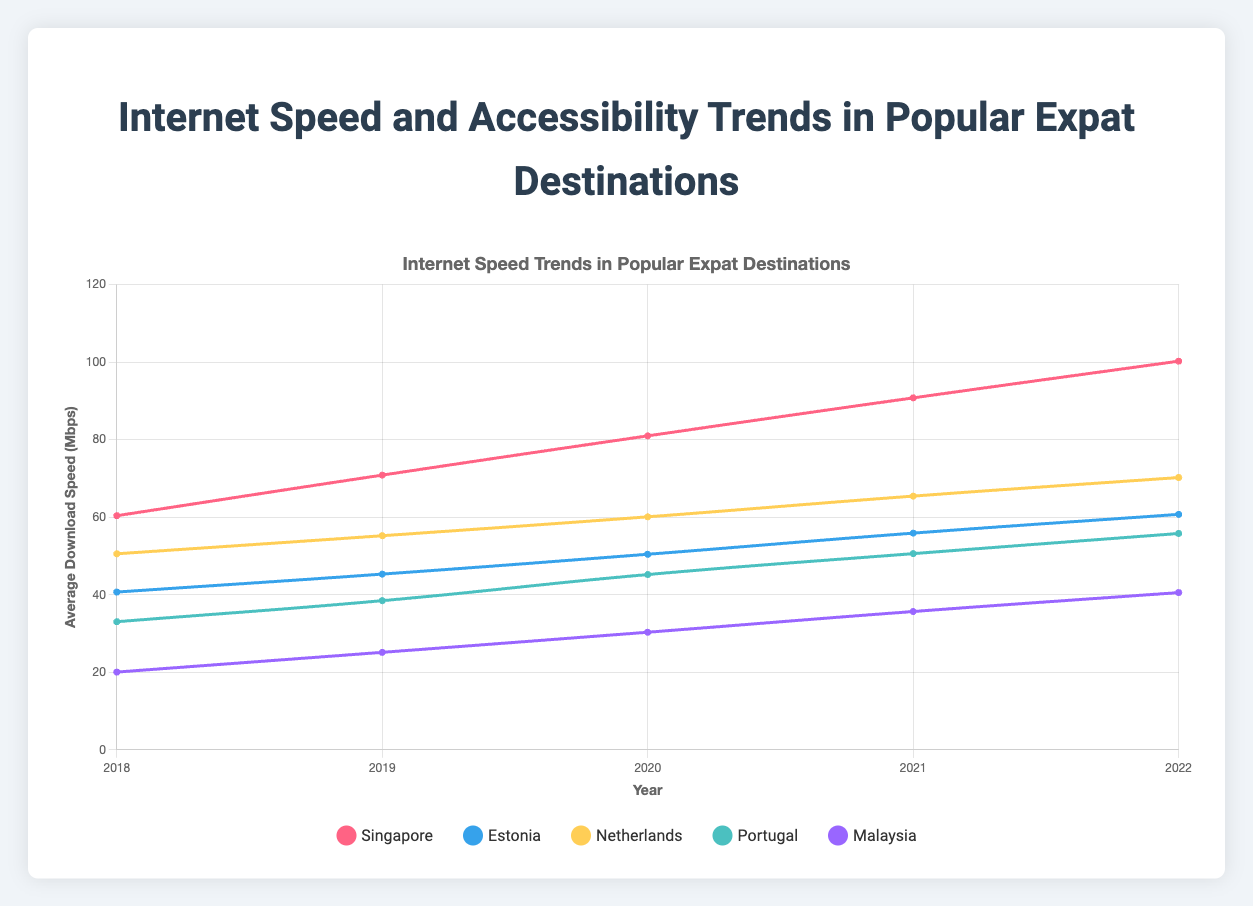What's the overall trend for internet speed in Singapore from 2018 to 2022? The line chart for Singapore shows a steady increase in average download speed from 60.39 Mbps in 2018 to 100.25 Mbps in 2022. By observing the plotted line, we can see consistent growth throughout these years.
Answer: Steady increase Which country had the highest accessibility score in 2020? By quickly scanning the lines and labels for accessibility scores, the highest value in 2020 is evident. Singapore had the highest accessibility score of 93, as indicated by the topmost point on the graph for that year.
Answer: Singapore In which year did Malaysia see the highest increase in average download speed compared to the previous year? Reviewing the line plot for Malaysia, the largest increase can be observed between 2018 and 2019, where the speed jumped from 20.05 Mbps to 25.14 Mbps, an increase of 5.09 Mbps.
Answer: 2019 How did Portugal's average download speed in 2022 compare to its speed in 2018? Portugal’s average download speed in 2018 was 33.04 Mbps, and in 2022 it was 55.80 Mbps. The comparison calculation shows that the speed increased by 22.76 Mbps over these years.
Answer: Increased by 22.76 Mbps Which country had the lowest average download speed in 2021? Scanning the chart for the lowest point in 2021, Malaysia shows the lowest average download speed at 35.67 Mbps. This can be seen by observing the bottommost line for that year.
Answer: Malaysia What is the combined average download speed for Estonia and Netherlands in 2022? For 2022, Estonia's speed is 60.73 Mbps and the Netherlands' speed is 70.23 Mbps. The combined average is calculated as (60.73 + 70.23) / 2.
Answer: 65.48 Mbps Compare the average download speed growth between Singapore and Estonia from 2018 to 2022. Singapore's download speed grew from 60.39 Mbps to 100.25 Mbps, an increase of 39.86 Mbps. Estonia's download speed grew from 40.69 Mbps to 60.73 Mbps, an increase of 20.04 Mbps. Therefore, Singapore had a larger increase in speed.
Answer: Singapore had greater growth Which country had the most consistent increase in internet speed over the years? By observing the trend lines, Netherlands shows a consistent, steady increase in its internet speed each year, without any sharp fluctuations.
Answer: Netherlands How did Malaysia's accessibility score change from 2018 to 2022? In 2018, Malaysia's accessibility score was 75, and it increased to 85 by 2022. The change is calculated by the difference, showing an increase of 10.
Answer: Increased by 10 Which two countries had the closest average download speeds in 2020? Looking at the plotted lines for 2020, Netherlands with 60.10 Mbps, and Estonia with 50.44 Mbps, seem close. Comparing other pairs, these two countries have the closest speeds with a difference of 9.66 Mbps.
Answer: Netherlands and Estonia 